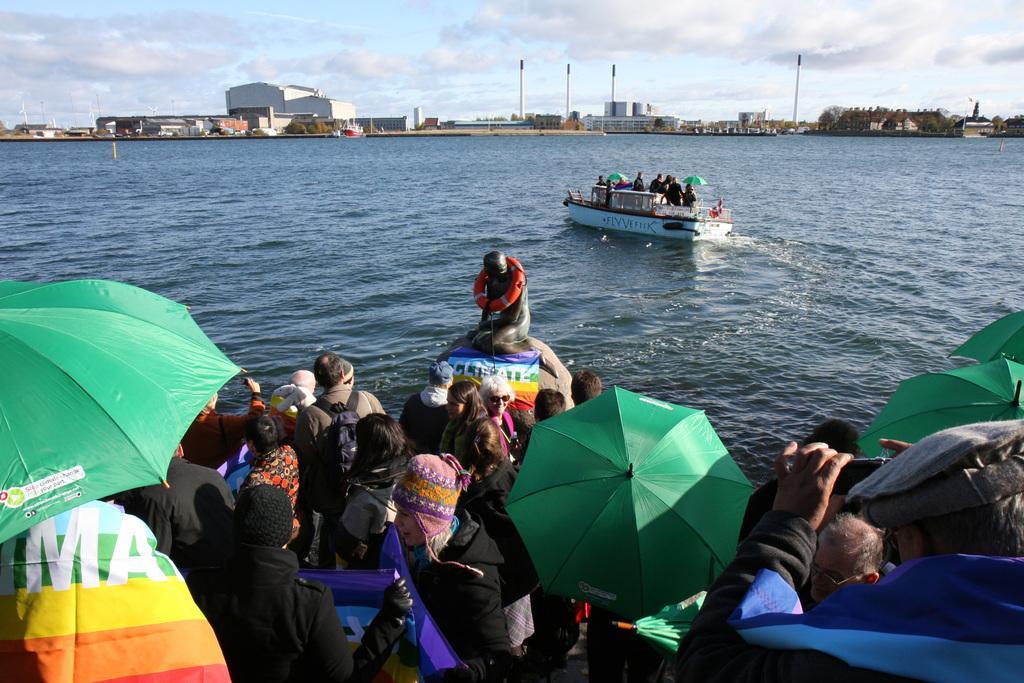In one or two sentences, can you explain what this image depicts? In the foreground of this image, there are persons holding umbrellas in their hands on the boat. In the background, we can see a person sitting on a ball in water, a boat, buildings, poles, trees, the sky and the cloud. 